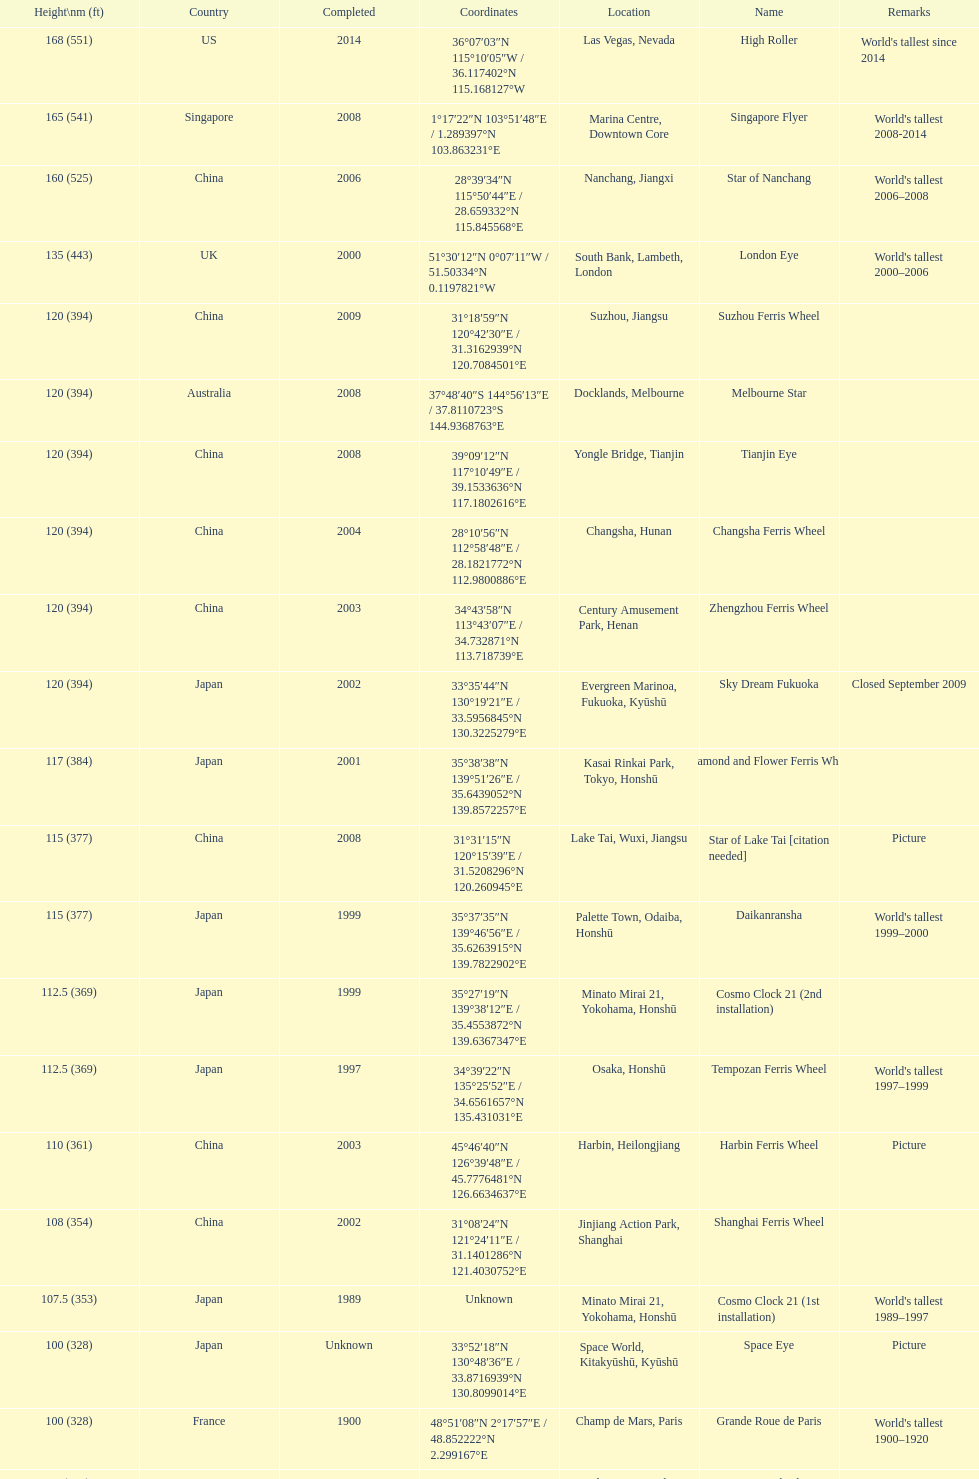Which country had the most roller coasters over 80 feet in height in 2008? China. 